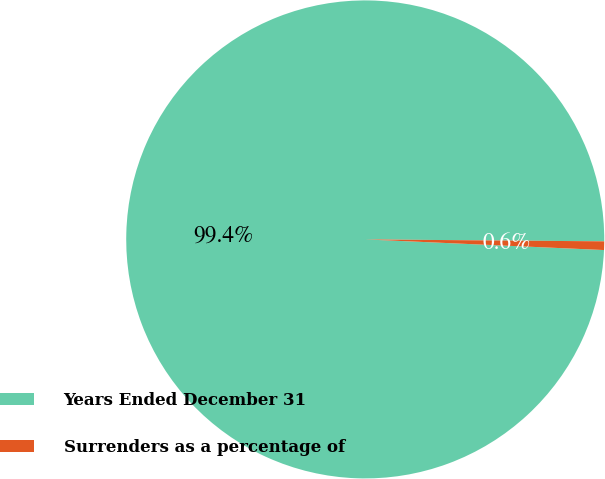Convert chart to OTSL. <chart><loc_0><loc_0><loc_500><loc_500><pie_chart><fcel>Years Ended December 31<fcel>Surrenders as a percentage of<nl><fcel>99.42%<fcel>0.58%<nl></chart> 